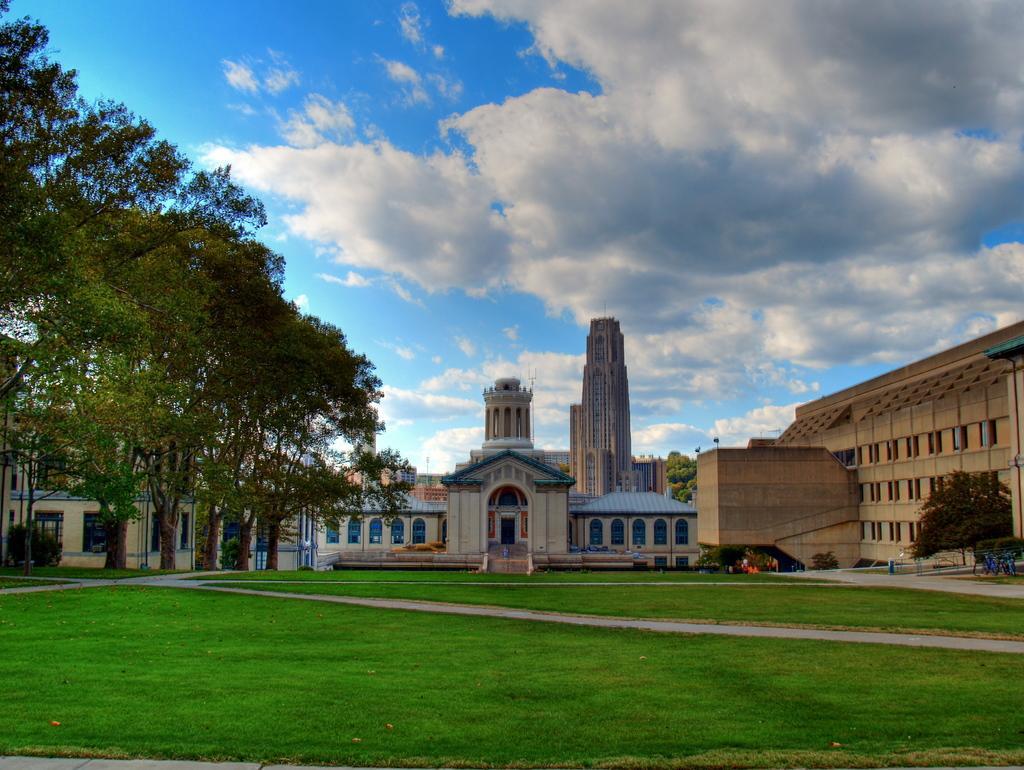In one or two sentences, can you explain what this image depicts? There are buildings and trees, these is grass and a sky. 